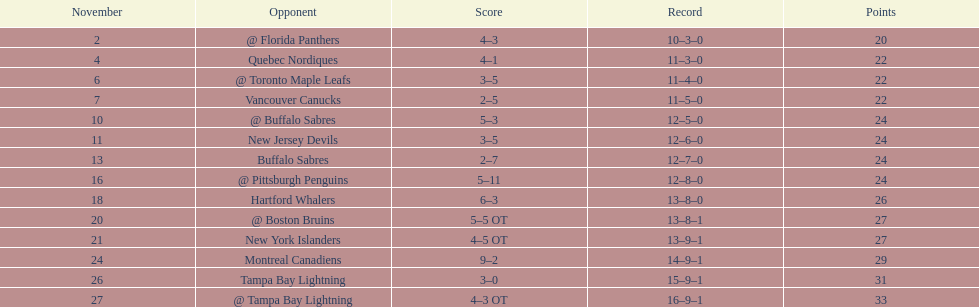What other team had the closest amount of wins? New York Islanders. 